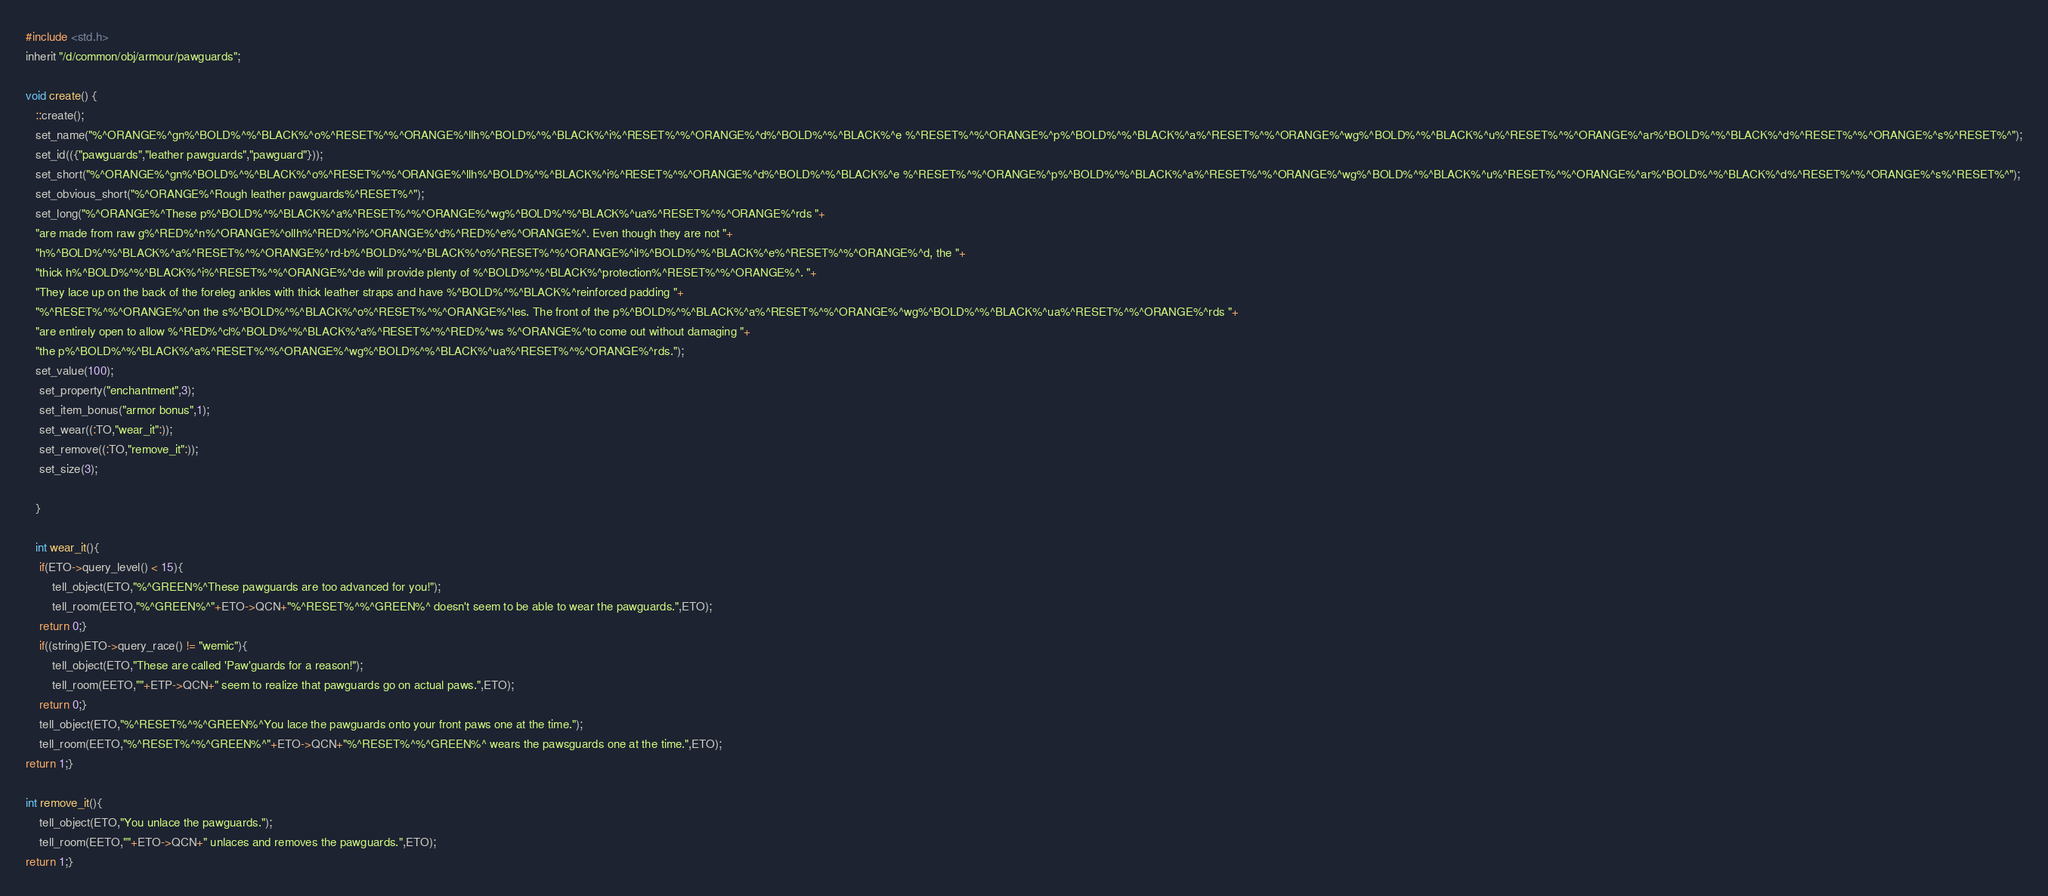<code> <loc_0><loc_0><loc_500><loc_500><_C_>#include <std.h>
inherit "/d/common/obj/armour/pawguards";

void create() {
   ::create();
   set_name("%^ORANGE%^gn%^BOLD%^%^BLACK%^o%^RESET%^%^ORANGE%^llh%^BOLD%^%^BLACK%^i%^RESET%^%^ORANGE%^d%^BOLD%^%^BLACK%^e %^RESET%^%^ORANGE%^p%^BOLD%^%^BLACK%^a%^RESET%^%^ORANGE%^wg%^BOLD%^%^BLACK%^u%^RESET%^%^ORANGE%^ar%^BOLD%^%^BLACK%^d%^RESET%^%^ORANGE%^s%^RESET%^");
   set_id(({"pawguards","leather pawguards","pawguard"}));
   set_short("%^ORANGE%^gn%^BOLD%^%^BLACK%^o%^RESET%^%^ORANGE%^llh%^BOLD%^%^BLACK%^i%^RESET%^%^ORANGE%^d%^BOLD%^%^BLACK%^e %^RESET%^%^ORANGE%^p%^BOLD%^%^BLACK%^a%^RESET%^%^ORANGE%^wg%^BOLD%^%^BLACK%^u%^RESET%^%^ORANGE%^ar%^BOLD%^%^BLACK%^d%^RESET%^%^ORANGE%^s%^RESET%^");
   set_obvious_short("%^ORANGE%^Rough leather pawguards%^RESET%^");
   set_long("%^ORANGE%^These p%^BOLD%^%^BLACK%^a%^RESET%^%^ORANGE%^wg%^BOLD%^%^BLACK%^ua%^RESET%^%^ORANGE%^rds "+
   "are made from raw g%^RED%^n%^ORANGE%^ollh%^RED%^i%^ORANGE%^d%^RED%^e%^ORANGE%^. Even though they are not "+
   "h%^BOLD%^%^BLACK%^a%^RESET%^%^ORANGE%^rd-b%^BOLD%^%^BLACK%^o%^RESET%^%^ORANGE%^il%^BOLD%^%^BLACK%^e%^RESET%^%^ORANGE%^d, the "+
   "thick h%^BOLD%^%^BLACK%^i%^RESET%^%^ORANGE%^de will provide plenty of %^BOLD%^%^BLACK%^protection%^RESET%^%^ORANGE%^. "+
   "They lace up on the back of the foreleg ankles with thick leather straps and have %^BOLD%^%^BLACK%^reinforced padding "+
   "%^RESET%^%^ORANGE%^on the s%^BOLD%^%^BLACK%^o%^RESET%^%^ORANGE%^les. The front of the p%^BOLD%^%^BLACK%^a%^RESET%^%^ORANGE%^wg%^BOLD%^%^BLACK%^ua%^RESET%^%^ORANGE%^rds "+
   "are entirely open to allow %^RED%^cl%^BOLD%^%^BLACK%^a%^RESET%^%^RED%^ws %^ORANGE%^to come out without damaging "+
   "the p%^BOLD%^%^BLACK%^a%^RESET%^%^ORANGE%^wg%^BOLD%^%^BLACK%^ua%^RESET%^%^ORANGE%^rds.");
   set_value(100);
	set_property("enchantment",3);
	set_item_bonus("armor bonus",1);
	set_wear((:TO,"wear_it":));
    set_remove((:TO,"remove_it":));
	set_size(3);
   
   }

   int wear_it(){
	if(ETO->query_level() < 15){
		tell_object(ETO,"%^GREEN%^These pawguards are too advanced for you!");
		tell_room(EETO,"%^GREEN%^"+ETO->QCN+"%^RESET%^%^GREEN%^ doesn't seem to be able to wear the pawguards.",ETO);
	return 0;}
	if((string)ETO->query_race() != "wemic"){
		tell_object(ETO,"These are called 'Paw'guards for a reason!");
		tell_room(EETO,""+ETP->QCN+" seem to realize that pawguards go on actual paws.",ETO);
	return 0;}
	tell_object(ETO,"%^RESET%^%^GREEN%^You lace the pawguards onto your front paws one at the time.");
	tell_room(EETO,"%^RESET%^%^GREEN%^"+ETO->QCN+"%^RESET%^%^GREEN%^ wears the pawsguards one at the time.",ETO);
return 1;}

int remove_it(){
	tell_object(ETO,"You unlace the pawguards.");
	tell_room(EETO,""+ETO->QCN+" unlaces and removes the pawguards.",ETO);
return 1;}</code> 